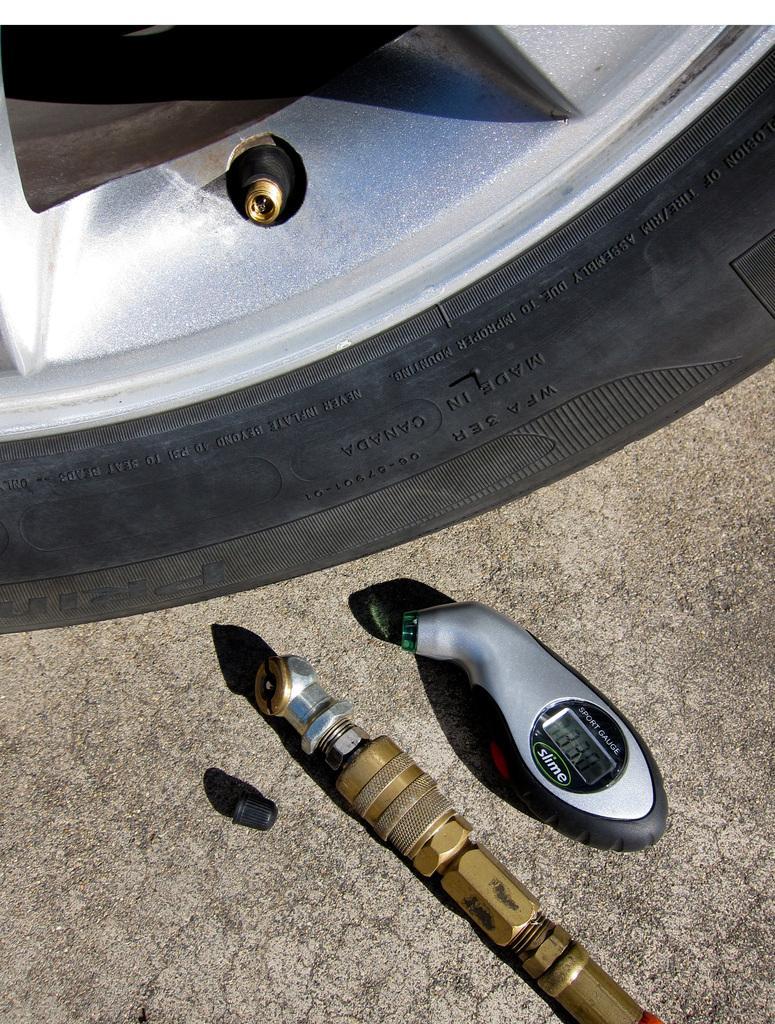Can you describe this image briefly? In the image there is a car tire in the back with a pressure measuring device and a pipe in the front. 